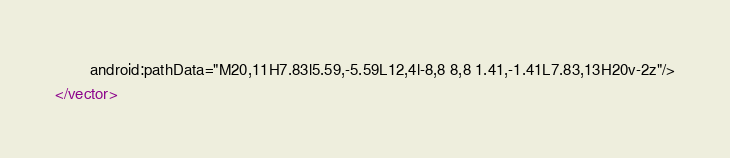<code> <loc_0><loc_0><loc_500><loc_500><_XML_>        android:pathData="M20,11H7.83l5.59,-5.59L12,4l-8,8 8,8 1.41,-1.41L7.83,13H20v-2z"/>
</vector>
</code> 